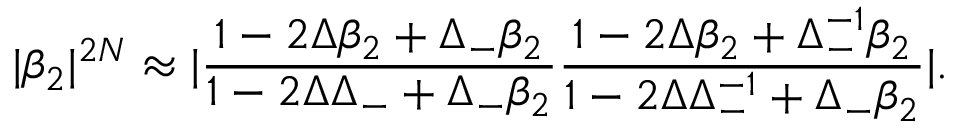<formula> <loc_0><loc_0><loc_500><loc_500>| \beta _ { 2 } | ^ { 2 N } \approx | \frac { 1 - 2 \Delta \beta _ { 2 } + \Delta _ { - } \beta _ { 2 } } { 1 - 2 \Delta \Delta _ { - } + \Delta _ { - } \beta _ { 2 } } \frac { 1 - 2 \Delta \beta _ { 2 } + \Delta _ { - } ^ { - 1 } \beta _ { 2 } } { 1 - 2 \Delta \Delta _ { - } ^ { - 1 } + \Delta _ { - } \beta _ { 2 } } | .</formula> 